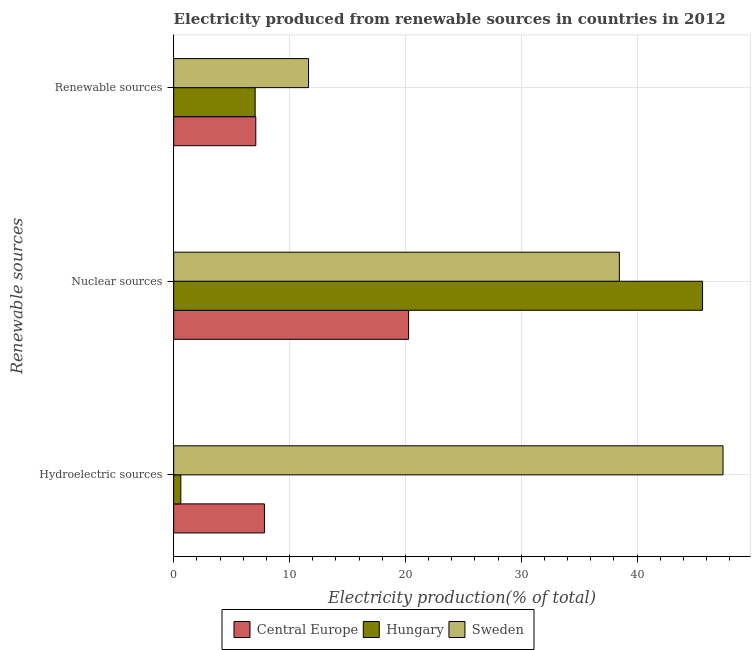Are the number of bars on each tick of the Y-axis equal?
Give a very brief answer. Yes. How many bars are there on the 1st tick from the top?
Offer a terse response. 3. How many bars are there on the 3rd tick from the bottom?
Provide a succinct answer. 3. What is the label of the 1st group of bars from the top?
Your answer should be compact. Renewable sources. What is the percentage of electricity produced by hydroelectric sources in Sweden?
Make the answer very short. 47.42. Across all countries, what is the maximum percentage of electricity produced by hydroelectric sources?
Your answer should be very brief. 47.42. Across all countries, what is the minimum percentage of electricity produced by hydroelectric sources?
Make the answer very short. 0.62. In which country was the percentage of electricity produced by renewable sources maximum?
Your answer should be very brief. Sweden. In which country was the percentage of electricity produced by nuclear sources minimum?
Provide a succinct answer. Central Europe. What is the total percentage of electricity produced by renewable sources in the graph?
Offer a terse response. 25.77. What is the difference between the percentage of electricity produced by hydroelectric sources in Hungary and that in Central Europe?
Your response must be concise. -7.22. What is the difference between the percentage of electricity produced by renewable sources in Hungary and the percentage of electricity produced by nuclear sources in Sweden?
Your answer should be very brief. -31.44. What is the average percentage of electricity produced by nuclear sources per country?
Offer a terse response. 34.8. What is the difference between the percentage of electricity produced by nuclear sources and percentage of electricity produced by renewable sources in Hungary?
Provide a short and direct response. 38.62. In how many countries, is the percentage of electricity produced by nuclear sources greater than 12 %?
Give a very brief answer. 3. What is the ratio of the percentage of electricity produced by nuclear sources in Sweden to that in Hungary?
Your response must be concise. 0.84. Is the percentage of electricity produced by hydroelectric sources in Sweden less than that in Hungary?
Provide a succinct answer. No. What is the difference between the highest and the second highest percentage of electricity produced by hydroelectric sources?
Offer a terse response. 39.59. What is the difference between the highest and the lowest percentage of electricity produced by renewable sources?
Provide a succinct answer. 4.61. In how many countries, is the percentage of electricity produced by nuclear sources greater than the average percentage of electricity produced by nuclear sources taken over all countries?
Your answer should be very brief. 2. Is the sum of the percentage of electricity produced by renewable sources in Sweden and Central Europe greater than the maximum percentage of electricity produced by hydroelectric sources across all countries?
Give a very brief answer. No. What does the 1st bar from the top in Nuclear sources represents?
Your answer should be very brief. Sweden. What does the 3rd bar from the bottom in Renewable sources represents?
Your response must be concise. Sweden. Are all the bars in the graph horizontal?
Keep it short and to the point. Yes. How many countries are there in the graph?
Your answer should be compact. 3. Does the graph contain any zero values?
Offer a very short reply. No. How are the legend labels stacked?
Your answer should be compact. Horizontal. What is the title of the graph?
Offer a very short reply. Electricity produced from renewable sources in countries in 2012. Does "Sint Maarten (Dutch part)" appear as one of the legend labels in the graph?
Keep it short and to the point. No. What is the label or title of the X-axis?
Offer a terse response. Electricity production(% of total). What is the label or title of the Y-axis?
Make the answer very short. Renewable sources. What is the Electricity production(% of total) of Central Europe in Hydroelectric sources?
Offer a terse response. 7.84. What is the Electricity production(% of total) of Hungary in Hydroelectric sources?
Offer a terse response. 0.62. What is the Electricity production(% of total) of Sweden in Hydroelectric sources?
Give a very brief answer. 47.42. What is the Electricity production(% of total) in Central Europe in Nuclear sources?
Offer a terse response. 20.28. What is the Electricity production(% of total) of Hungary in Nuclear sources?
Make the answer very short. 45.66. What is the Electricity production(% of total) in Sweden in Nuclear sources?
Your answer should be compact. 38.48. What is the Electricity production(% of total) in Central Europe in Renewable sources?
Provide a succinct answer. 7.09. What is the Electricity production(% of total) of Hungary in Renewable sources?
Ensure brevity in your answer.  7.03. What is the Electricity production(% of total) in Sweden in Renewable sources?
Your answer should be compact. 11.64. Across all Renewable sources, what is the maximum Electricity production(% of total) in Central Europe?
Your answer should be compact. 20.28. Across all Renewable sources, what is the maximum Electricity production(% of total) in Hungary?
Your answer should be very brief. 45.66. Across all Renewable sources, what is the maximum Electricity production(% of total) of Sweden?
Provide a short and direct response. 47.42. Across all Renewable sources, what is the minimum Electricity production(% of total) of Central Europe?
Provide a succinct answer. 7.09. Across all Renewable sources, what is the minimum Electricity production(% of total) in Hungary?
Your answer should be compact. 0.62. Across all Renewable sources, what is the minimum Electricity production(% of total) in Sweden?
Keep it short and to the point. 11.64. What is the total Electricity production(% of total) in Central Europe in the graph?
Your answer should be compact. 35.21. What is the total Electricity production(% of total) of Hungary in the graph?
Keep it short and to the point. 53.31. What is the total Electricity production(% of total) of Sweden in the graph?
Give a very brief answer. 97.54. What is the difference between the Electricity production(% of total) in Central Europe in Hydroelectric sources and that in Nuclear sources?
Offer a terse response. -12.44. What is the difference between the Electricity production(% of total) of Hungary in Hydroelectric sources and that in Nuclear sources?
Your answer should be compact. -45.04. What is the difference between the Electricity production(% of total) in Sweden in Hydroelectric sources and that in Nuclear sources?
Provide a short and direct response. 8.95. What is the difference between the Electricity production(% of total) of Central Europe in Hydroelectric sources and that in Renewable sources?
Your response must be concise. 0.75. What is the difference between the Electricity production(% of total) in Hungary in Hydroelectric sources and that in Renewable sources?
Offer a terse response. -6.42. What is the difference between the Electricity production(% of total) of Sweden in Hydroelectric sources and that in Renewable sources?
Your answer should be compact. 35.78. What is the difference between the Electricity production(% of total) of Central Europe in Nuclear sources and that in Renewable sources?
Provide a succinct answer. 13.19. What is the difference between the Electricity production(% of total) of Hungary in Nuclear sources and that in Renewable sources?
Keep it short and to the point. 38.62. What is the difference between the Electricity production(% of total) in Sweden in Nuclear sources and that in Renewable sources?
Provide a short and direct response. 26.83. What is the difference between the Electricity production(% of total) of Central Europe in Hydroelectric sources and the Electricity production(% of total) of Hungary in Nuclear sources?
Ensure brevity in your answer.  -37.82. What is the difference between the Electricity production(% of total) in Central Europe in Hydroelectric sources and the Electricity production(% of total) in Sweden in Nuclear sources?
Provide a short and direct response. -30.64. What is the difference between the Electricity production(% of total) in Hungary in Hydroelectric sources and the Electricity production(% of total) in Sweden in Nuclear sources?
Keep it short and to the point. -37.86. What is the difference between the Electricity production(% of total) in Central Europe in Hydroelectric sources and the Electricity production(% of total) in Hungary in Renewable sources?
Offer a terse response. 0.8. What is the difference between the Electricity production(% of total) of Central Europe in Hydroelectric sources and the Electricity production(% of total) of Sweden in Renewable sources?
Give a very brief answer. -3.81. What is the difference between the Electricity production(% of total) in Hungary in Hydroelectric sources and the Electricity production(% of total) in Sweden in Renewable sources?
Provide a short and direct response. -11.03. What is the difference between the Electricity production(% of total) of Central Europe in Nuclear sources and the Electricity production(% of total) of Hungary in Renewable sources?
Make the answer very short. 13.25. What is the difference between the Electricity production(% of total) in Central Europe in Nuclear sources and the Electricity production(% of total) in Sweden in Renewable sources?
Ensure brevity in your answer.  8.64. What is the difference between the Electricity production(% of total) of Hungary in Nuclear sources and the Electricity production(% of total) of Sweden in Renewable sources?
Keep it short and to the point. 34.01. What is the average Electricity production(% of total) in Central Europe per Renewable sources?
Your response must be concise. 11.74. What is the average Electricity production(% of total) of Hungary per Renewable sources?
Your answer should be very brief. 17.77. What is the average Electricity production(% of total) of Sweden per Renewable sources?
Make the answer very short. 32.51. What is the difference between the Electricity production(% of total) of Central Europe and Electricity production(% of total) of Hungary in Hydroelectric sources?
Your response must be concise. 7.22. What is the difference between the Electricity production(% of total) of Central Europe and Electricity production(% of total) of Sweden in Hydroelectric sources?
Provide a short and direct response. -39.59. What is the difference between the Electricity production(% of total) of Hungary and Electricity production(% of total) of Sweden in Hydroelectric sources?
Provide a short and direct response. -46.81. What is the difference between the Electricity production(% of total) in Central Europe and Electricity production(% of total) in Hungary in Nuclear sources?
Provide a short and direct response. -25.38. What is the difference between the Electricity production(% of total) in Central Europe and Electricity production(% of total) in Sweden in Nuclear sources?
Make the answer very short. -18.19. What is the difference between the Electricity production(% of total) of Hungary and Electricity production(% of total) of Sweden in Nuclear sources?
Make the answer very short. 7.18. What is the difference between the Electricity production(% of total) in Central Europe and Electricity production(% of total) in Hungary in Renewable sources?
Keep it short and to the point. 0.06. What is the difference between the Electricity production(% of total) of Central Europe and Electricity production(% of total) of Sweden in Renewable sources?
Provide a short and direct response. -4.55. What is the difference between the Electricity production(% of total) in Hungary and Electricity production(% of total) in Sweden in Renewable sources?
Your answer should be compact. -4.61. What is the ratio of the Electricity production(% of total) in Central Europe in Hydroelectric sources to that in Nuclear sources?
Provide a short and direct response. 0.39. What is the ratio of the Electricity production(% of total) in Hungary in Hydroelectric sources to that in Nuclear sources?
Offer a terse response. 0.01. What is the ratio of the Electricity production(% of total) in Sweden in Hydroelectric sources to that in Nuclear sources?
Your answer should be very brief. 1.23. What is the ratio of the Electricity production(% of total) in Central Europe in Hydroelectric sources to that in Renewable sources?
Offer a very short reply. 1.11. What is the ratio of the Electricity production(% of total) in Hungary in Hydroelectric sources to that in Renewable sources?
Provide a succinct answer. 0.09. What is the ratio of the Electricity production(% of total) of Sweden in Hydroelectric sources to that in Renewable sources?
Ensure brevity in your answer.  4.07. What is the ratio of the Electricity production(% of total) in Central Europe in Nuclear sources to that in Renewable sources?
Your response must be concise. 2.86. What is the ratio of the Electricity production(% of total) of Hungary in Nuclear sources to that in Renewable sources?
Your response must be concise. 6.49. What is the ratio of the Electricity production(% of total) in Sweden in Nuclear sources to that in Renewable sources?
Your answer should be compact. 3.3. What is the difference between the highest and the second highest Electricity production(% of total) of Central Europe?
Your answer should be compact. 12.44. What is the difference between the highest and the second highest Electricity production(% of total) of Hungary?
Make the answer very short. 38.62. What is the difference between the highest and the second highest Electricity production(% of total) of Sweden?
Keep it short and to the point. 8.95. What is the difference between the highest and the lowest Electricity production(% of total) in Central Europe?
Your answer should be very brief. 13.19. What is the difference between the highest and the lowest Electricity production(% of total) in Hungary?
Provide a succinct answer. 45.04. What is the difference between the highest and the lowest Electricity production(% of total) in Sweden?
Offer a very short reply. 35.78. 